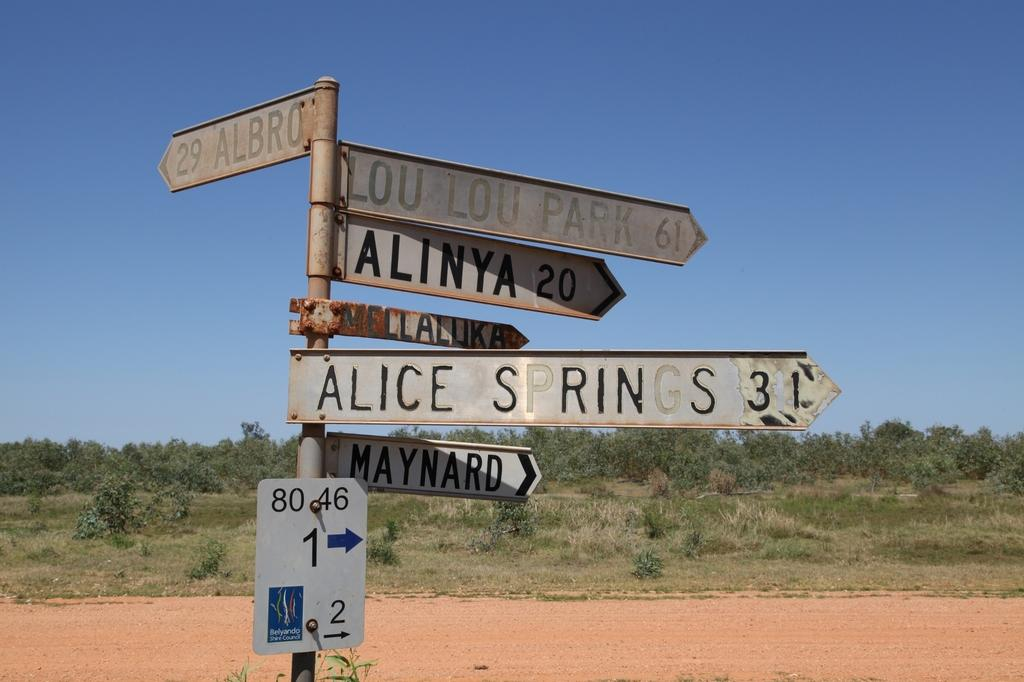<image>
Render a clear and concise summary of the photo. some signs with one that says alice on it 